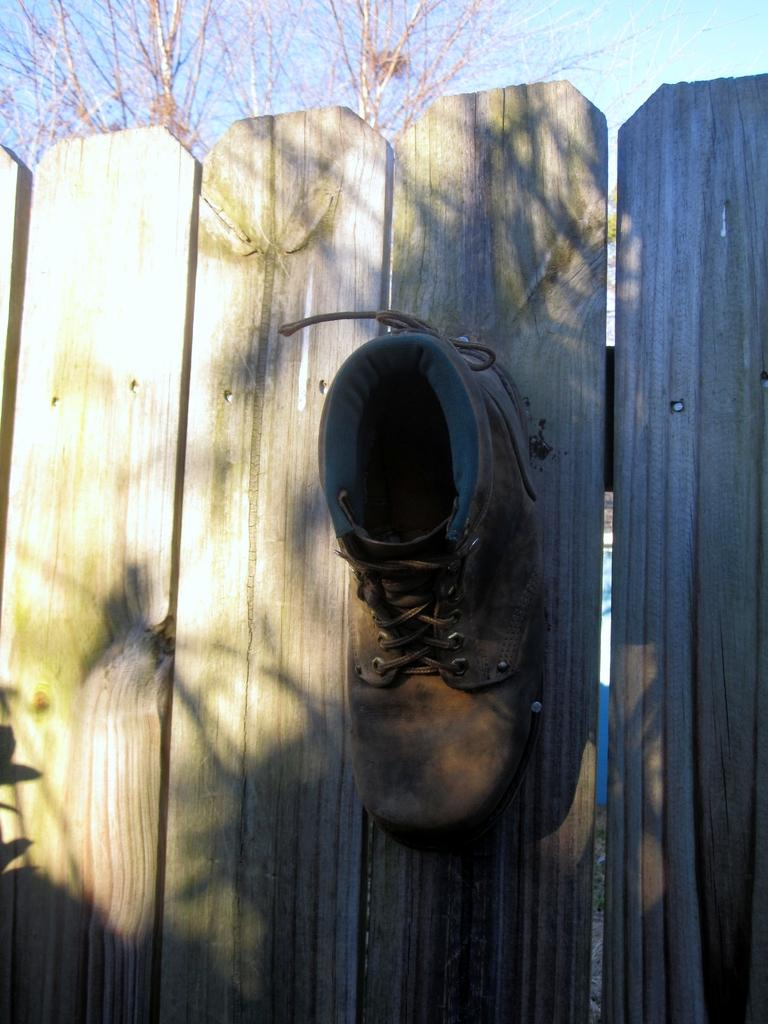What object is placed on the wooden fence in the image? There is a shoe on a wooden fence in the image. What type of vegetation can be seen in the background of the image? There is a tree at the back of the image. What is visible at the top of the image? The sky is visible at the top of the image. What type of oatmeal is being served in the image? There is no oatmeal present in the image. 